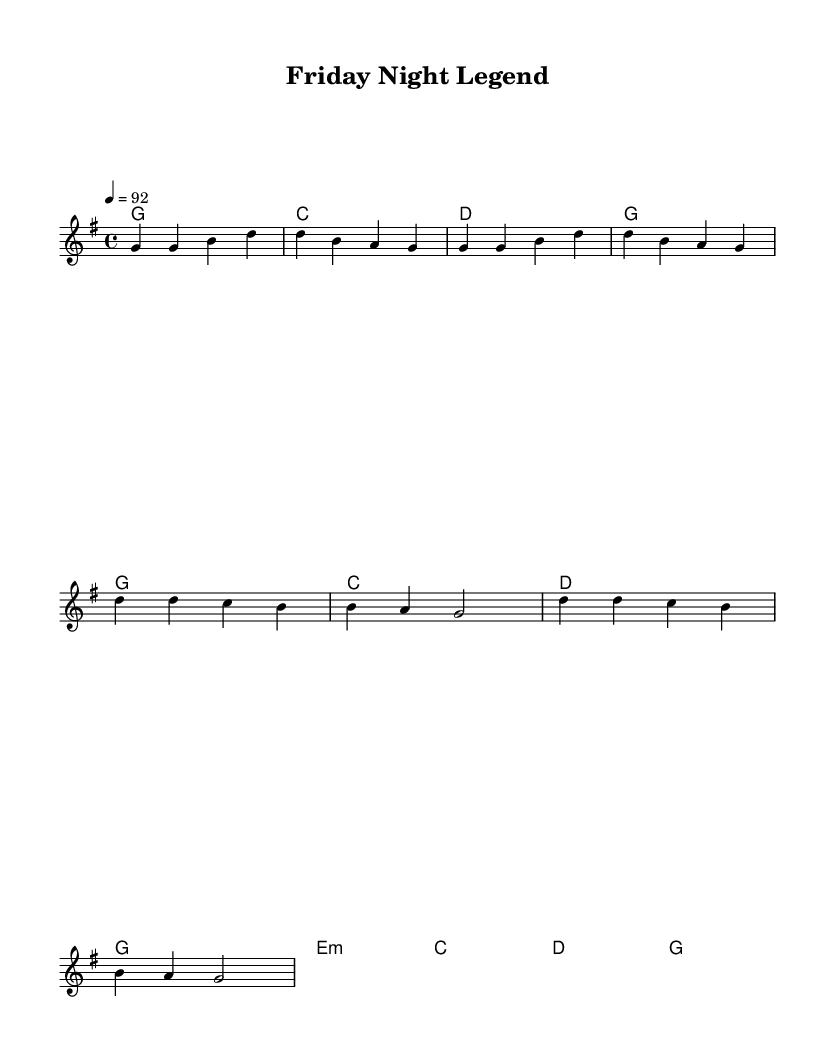What is the key signature of this music? The key signature is G major, which has one sharp (F#). This is indicated at the beginning of the score.
Answer: G major What is the time signature of this music? The time signature is 4/4, which means there are four beats in each measure and a quarter note receives one beat. This can be seen in the beginning of the score.
Answer: 4/4 What is the tempo of this piece? The tempo marking is 92 beats per minute, indicated by the number 4 = 92 at the start, specifying the speed of the music.
Answer: 92 How many measures are in the verse section? The verse consists of eight measures total, counted from the melody notation provided in the score. Each group of notes separated by vertical bars represents one measure.
Answer: Eight How many distinct chords are used in the chorus? The chorus contains five distinct chords: G, C, D, E minor, and G. This is determined by analyzing the chord changes indicated in the harmony section of the score.
Answer: Five What lyrical theme is represented in this music? The lyrics reminisce about small-town sports heroes and their legacy, as seen in phrases like "hometown hero" and "under those bright lights," reflecting nostalgia and pride.
Answer: Nostalgia 